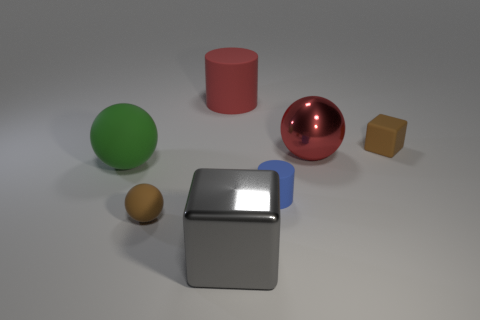How many objects have the same color as the small rubber cube?
Give a very brief answer. 1. There is a thing that is the same color as the small ball; what is its material?
Provide a short and direct response. Rubber. The small thing that is behind the small rubber sphere and in front of the large green ball is made of what material?
Offer a terse response. Rubber. The large green thing that is the same material as the small brown cube is what shape?
Make the answer very short. Sphere. There is a green ball that is the same material as the small brown block; what size is it?
Ensure brevity in your answer.  Large. There is a big thing that is both on the right side of the red matte thing and behind the big metallic block; what is its shape?
Offer a very short reply. Sphere. How big is the brown object that is left of the matte object to the right of the small blue object?
Give a very brief answer. Small. What number of other objects are there of the same color as the shiny block?
Your answer should be very brief. 0. What is the material of the brown sphere?
Provide a short and direct response. Rubber. Are any big brown balls visible?
Give a very brief answer. No. 